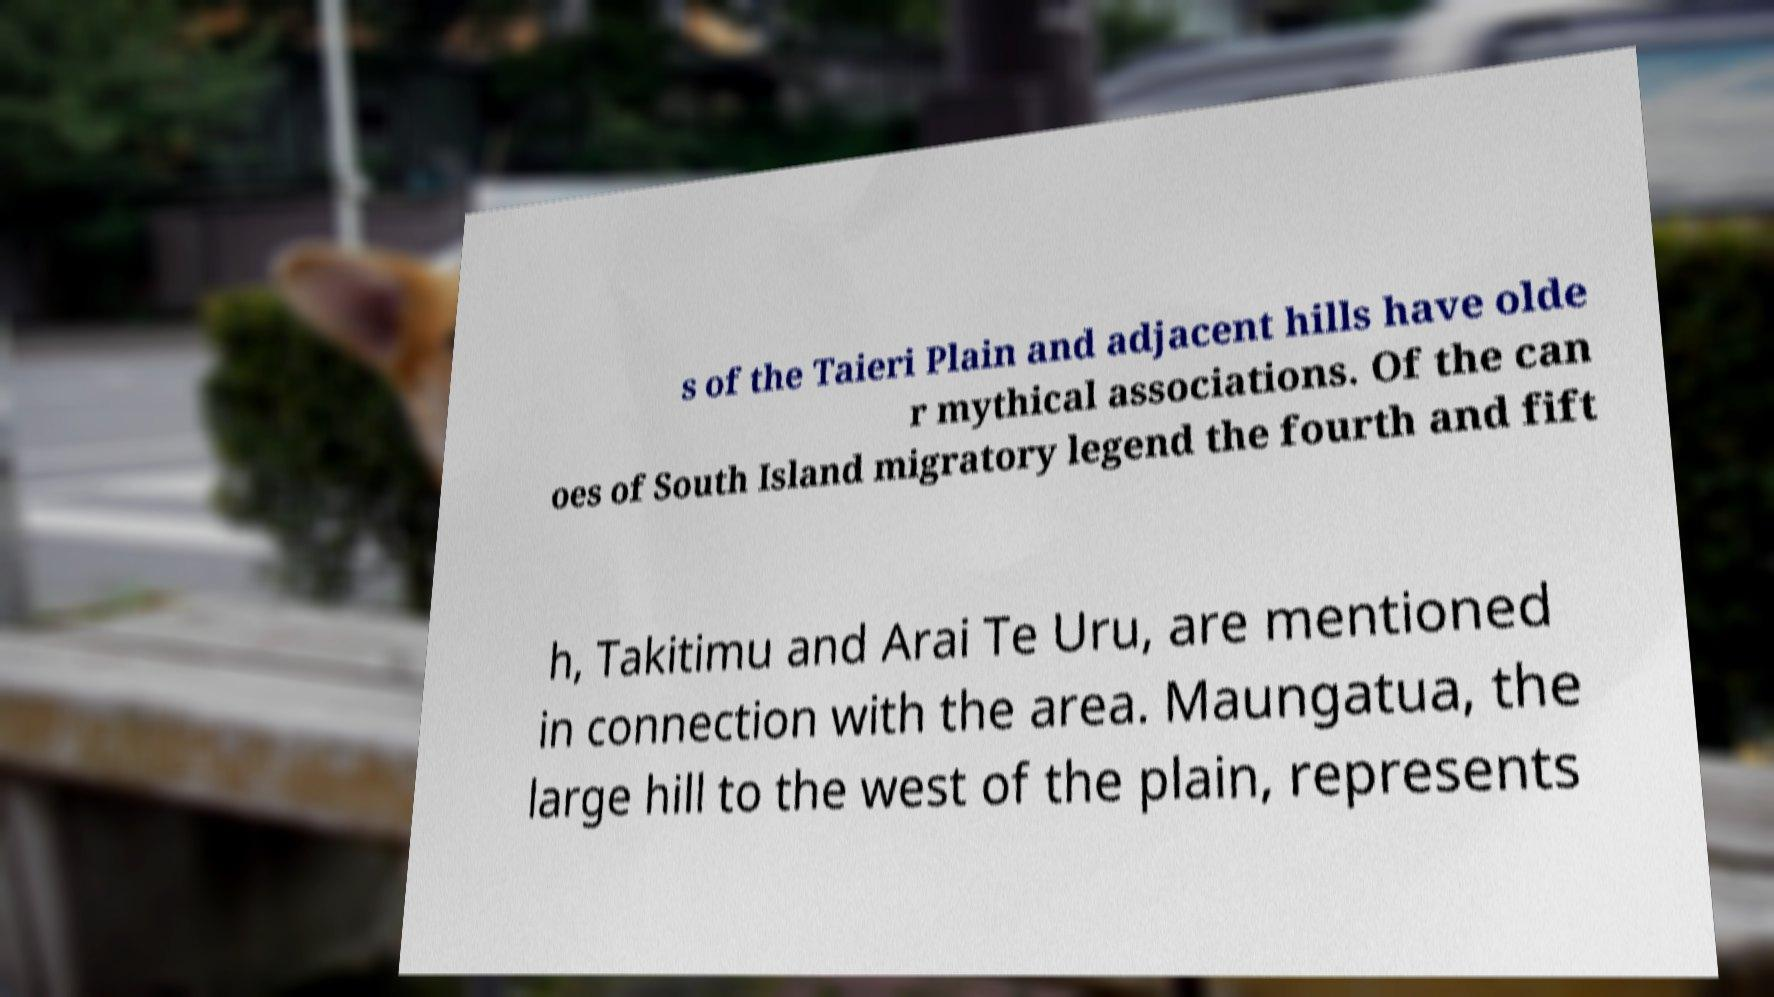Could you extract and type out the text from this image? s of the Taieri Plain and adjacent hills have olde r mythical associations. Of the can oes of South Island migratory legend the fourth and fift h, Takitimu and Arai Te Uru, are mentioned in connection with the area. Maungatua, the large hill to the west of the plain, represents 